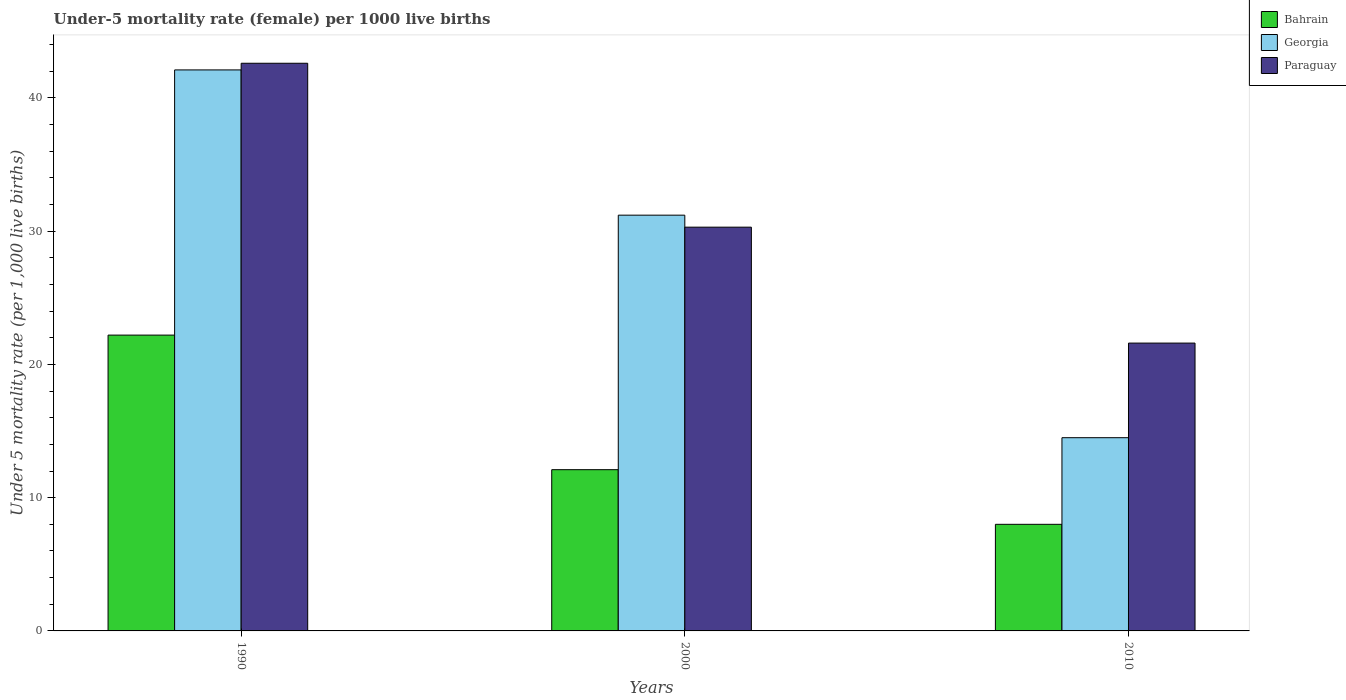What is the label of the 2nd group of bars from the left?
Provide a short and direct response. 2000. What is the under-five mortality rate in Bahrain in 2010?
Ensure brevity in your answer.  8. Across all years, what is the maximum under-five mortality rate in Georgia?
Give a very brief answer. 42.1. Across all years, what is the minimum under-five mortality rate in Bahrain?
Your answer should be very brief. 8. In which year was the under-five mortality rate in Bahrain maximum?
Your response must be concise. 1990. In which year was the under-five mortality rate in Paraguay minimum?
Provide a succinct answer. 2010. What is the total under-five mortality rate in Paraguay in the graph?
Provide a succinct answer. 94.5. What is the difference between the under-five mortality rate in Georgia in 1990 and that in 2010?
Your answer should be compact. 27.6. What is the difference between the under-five mortality rate in Georgia in 2000 and the under-five mortality rate in Paraguay in 2010?
Keep it short and to the point. 9.6. In the year 2000, what is the difference between the under-five mortality rate in Paraguay and under-five mortality rate in Georgia?
Offer a very short reply. -0.9. In how many years, is the under-five mortality rate in Bahrain greater than 6?
Your answer should be very brief. 3. What is the ratio of the under-five mortality rate in Bahrain in 1990 to that in 2000?
Keep it short and to the point. 1.83. Is the under-five mortality rate in Georgia in 1990 less than that in 2000?
Provide a short and direct response. No. Is the difference between the under-five mortality rate in Paraguay in 2000 and 2010 greater than the difference between the under-five mortality rate in Georgia in 2000 and 2010?
Offer a very short reply. No. What is the difference between the highest and the second highest under-five mortality rate in Bahrain?
Your response must be concise. 10.1. What is the difference between the highest and the lowest under-five mortality rate in Bahrain?
Make the answer very short. 14.2. Is the sum of the under-five mortality rate in Paraguay in 1990 and 2010 greater than the maximum under-five mortality rate in Georgia across all years?
Give a very brief answer. Yes. What does the 2nd bar from the left in 1990 represents?
Ensure brevity in your answer.  Georgia. What does the 1st bar from the right in 1990 represents?
Make the answer very short. Paraguay. Is it the case that in every year, the sum of the under-five mortality rate in Bahrain and under-five mortality rate in Paraguay is greater than the under-five mortality rate in Georgia?
Ensure brevity in your answer.  Yes. How many bars are there?
Give a very brief answer. 9. How many years are there in the graph?
Ensure brevity in your answer.  3. Are the values on the major ticks of Y-axis written in scientific E-notation?
Your answer should be compact. No. How many legend labels are there?
Your answer should be very brief. 3. What is the title of the graph?
Make the answer very short. Under-5 mortality rate (female) per 1000 live births. What is the label or title of the X-axis?
Your response must be concise. Years. What is the label or title of the Y-axis?
Your answer should be compact. Under 5 mortality rate (per 1,0 live births). What is the Under 5 mortality rate (per 1,000 live births) of Georgia in 1990?
Your answer should be very brief. 42.1. What is the Under 5 mortality rate (per 1,000 live births) of Paraguay in 1990?
Make the answer very short. 42.6. What is the Under 5 mortality rate (per 1,000 live births) of Georgia in 2000?
Your response must be concise. 31.2. What is the Under 5 mortality rate (per 1,000 live births) in Paraguay in 2000?
Your response must be concise. 30.3. What is the Under 5 mortality rate (per 1,000 live births) in Bahrain in 2010?
Your answer should be compact. 8. What is the Under 5 mortality rate (per 1,000 live births) of Georgia in 2010?
Give a very brief answer. 14.5. What is the Under 5 mortality rate (per 1,000 live births) in Paraguay in 2010?
Your answer should be very brief. 21.6. Across all years, what is the maximum Under 5 mortality rate (per 1,000 live births) of Bahrain?
Offer a terse response. 22.2. Across all years, what is the maximum Under 5 mortality rate (per 1,000 live births) in Georgia?
Your response must be concise. 42.1. Across all years, what is the maximum Under 5 mortality rate (per 1,000 live births) in Paraguay?
Provide a short and direct response. 42.6. Across all years, what is the minimum Under 5 mortality rate (per 1,000 live births) of Paraguay?
Give a very brief answer. 21.6. What is the total Under 5 mortality rate (per 1,000 live births) of Bahrain in the graph?
Offer a terse response. 42.3. What is the total Under 5 mortality rate (per 1,000 live births) of Georgia in the graph?
Ensure brevity in your answer.  87.8. What is the total Under 5 mortality rate (per 1,000 live births) of Paraguay in the graph?
Keep it short and to the point. 94.5. What is the difference between the Under 5 mortality rate (per 1,000 live births) of Bahrain in 1990 and that in 2000?
Give a very brief answer. 10.1. What is the difference between the Under 5 mortality rate (per 1,000 live births) of Bahrain in 1990 and that in 2010?
Your answer should be very brief. 14.2. What is the difference between the Under 5 mortality rate (per 1,000 live births) in Georgia in 1990 and that in 2010?
Offer a very short reply. 27.6. What is the difference between the Under 5 mortality rate (per 1,000 live births) in Paraguay in 1990 and that in 2010?
Ensure brevity in your answer.  21. What is the difference between the Under 5 mortality rate (per 1,000 live births) in Paraguay in 2000 and that in 2010?
Your answer should be very brief. 8.7. What is the difference between the Under 5 mortality rate (per 1,000 live births) of Bahrain in 1990 and the Under 5 mortality rate (per 1,000 live births) of Georgia in 2000?
Offer a very short reply. -9. What is the difference between the Under 5 mortality rate (per 1,000 live births) of Bahrain in 1990 and the Under 5 mortality rate (per 1,000 live births) of Paraguay in 2000?
Your answer should be very brief. -8.1. What is the difference between the Under 5 mortality rate (per 1,000 live births) of Georgia in 1990 and the Under 5 mortality rate (per 1,000 live births) of Paraguay in 2000?
Provide a succinct answer. 11.8. What is the difference between the Under 5 mortality rate (per 1,000 live births) in Bahrain in 1990 and the Under 5 mortality rate (per 1,000 live births) in Georgia in 2010?
Your response must be concise. 7.7. What is the difference between the Under 5 mortality rate (per 1,000 live births) in Bahrain in 2000 and the Under 5 mortality rate (per 1,000 live births) in Georgia in 2010?
Offer a very short reply. -2.4. What is the average Under 5 mortality rate (per 1,000 live births) in Bahrain per year?
Keep it short and to the point. 14.1. What is the average Under 5 mortality rate (per 1,000 live births) in Georgia per year?
Provide a succinct answer. 29.27. What is the average Under 5 mortality rate (per 1,000 live births) of Paraguay per year?
Your response must be concise. 31.5. In the year 1990, what is the difference between the Under 5 mortality rate (per 1,000 live births) of Bahrain and Under 5 mortality rate (per 1,000 live births) of Georgia?
Your response must be concise. -19.9. In the year 1990, what is the difference between the Under 5 mortality rate (per 1,000 live births) in Bahrain and Under 5 mortality rate (per 1,000 live births) in Paraguay?
Give a very brief answer. -20.4. In the year 1990, what is the difference between the Under 5 mortality rate (per 1,000 live births) of Georgia and Under 5 mortality rate (per 1,000 live births) of Paraguay?
Your response must be concise. -0.5. In the year 2000, what is the difference between the Under 5 mortality rate (per 1,000 live births) of Bahrain and Under 5 mortality rate (per 1,000 live births) of Georgia?
Provide a short and direct response. -19.1. In the year 2000, what is the difference between the Under 5 mortality rate (per 1,000 live births) in Bahrain and Under 5 mortality rate (per 1,000 live births) in Paraguay?
Your response must be concise. -18.2. In the year 2000, what is the difference between the Under 5 mortality rate (per 1,000 live births) in Georgia and Under 5 mortality rate (per 1,000 live births) in Paraguay?
Ensure brevity in your answer.  0.9. In the year 2010, what is the difference between the Under 5 mortality rate (per 1,000 live births) in Bahrain and Under 5 mortality rate (per 1,000 live births) in Paraguay?
Offer a very short reply. -13.6. What is the ratio of the Under 5 mortality rate (per 1,000 live births) in Bahrain in 1990 to that in 2000?
Your answer should be very brief. 1.83. What is the ratio of the Under 5 mortality rate (per 1,000 live births) in Georgia in 1990 to that in 2000?
Give a very brief answer. 1.35. What is the ratio of the Under 5 mortality rate (per 1,000 live births) of Paraguay in 1990 to that in 2000?
Your answer should be very brief. 1.41. What is the ratio of the Under 5 mortality rate (per 1,000 live births) of Bahrain in 1990 to that in 2010?
Offer a terse response. 2.77. What is the ratio of the Under 5 mortality rate (per 1,000 live births) in Georgia in 1990 to that in 2010?
Keep it short and to the point. 2.9. What is the ratio of the Under 5 mortality rate (per 1,000 live births) in Paraguay in 1990 to that in 2010?
Provide a succinct answer. 1.97. What is the ratio of the Under 5 mortality rate (per 1,000 live births) of Bahrain in 2000 to that in 2010?
Your response must be concise. 1.51. What is the ratio of the Under 5 mortality rate (per 1,000 live births) of Georgia in 2000 to that in 2010?
Provide a succinct answer. 2.15. What is the ratio of the Under 5 mortality rate (per 1,000 live births) of Paraguay in 2000 to that in 2010?
Provide a succinct answer. 1.4. What is the difference between the highest and the second highest Under 5 mortality rate (per 1,000 live births) of Georgia?
Ensure brevity in your answer.  10.9. What is the difference between the highest and the second highest Under 5 mortality rate (per 1,000 live births) of Paraguay?
Offer a very short reply. 12.3. What is the difference between the highest and the lowest Under 5 mortality rate (per 1,000 live births) of Georgia?
Give a very brief answer. 27.6. 